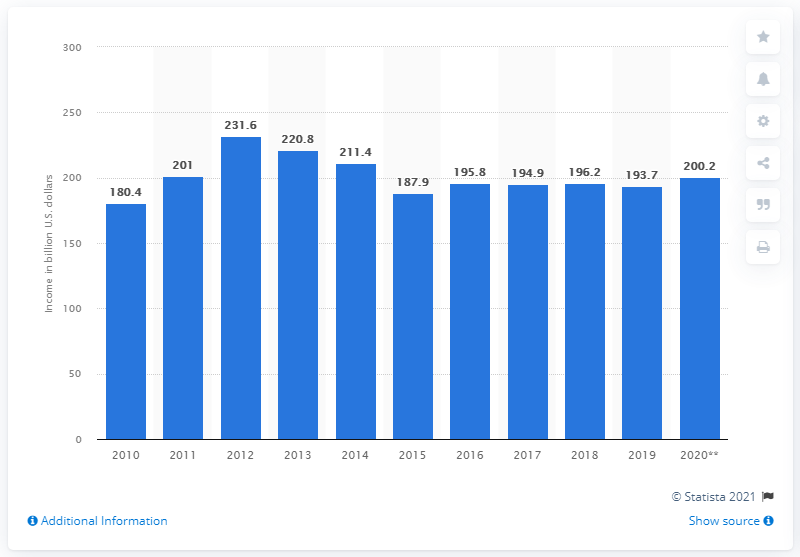Mention a couple of crucial points in this snapshot. According to data from the United States in 2020, crops earned a total of $200.2 billion in revenue. 